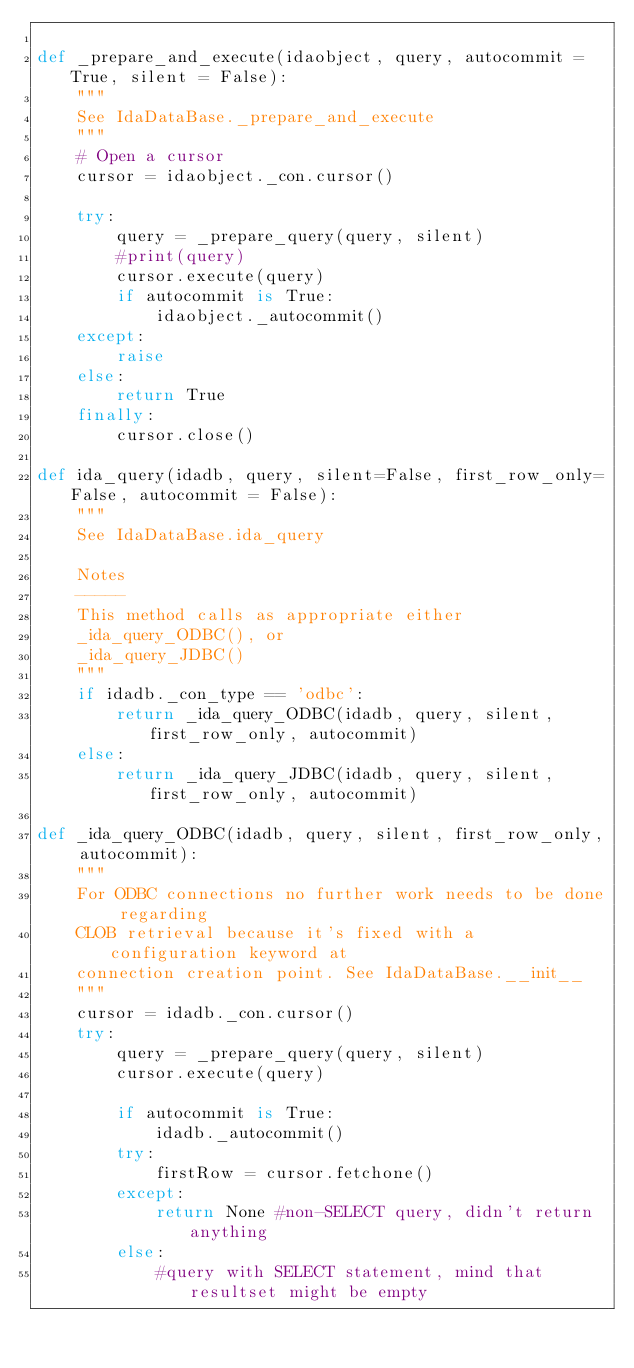Convert code to text. <code><loc_0><loc_0><loc_500><loc_500><_Python_>
def _prepare_and_execute(idaobject, query, autocommit = True, silent = False):
    """
    See IdaDataBase._prepare_and_execute
    """
    # Open a cursor
    cursor = idaobject._con.cursor()

    try:
        query = _prepare_query(query, silent)
        #print(query)
        cursor.execute(query)
        if autocommit is True:
            idaobject._autocommit()
    except:
        raise
    else:
        return True
    finally:
        cursor.close()

def ida_query(idadb, query, silent=False, first_row_only=False, autocommit = False):
    """
    See IdaDataBase.ida_query
    
    Notes
    -----
    This method calls as appropriate either 
    _ida_query_ODBC(), or 
    _ida_query_JDBC()
    """
    if idadb._con_type == 'odbc':
        return _ida_query_ODBC(idadb, query, silent, first_row_only, autocommit)
    else:
        return _ida_query_JDBC(idadb, query, silent, first_row_only, autocommit)

def _ida_query_ODBC(idadb, query, silent, first_row_only, autocommit):
    """
    For ODBC connections no further work needs to be done regarding
    CLOB retrieval because it's fixed with a configuration keyword at
    connection creation point. See IdaDataBase.__init__
    """
    cursor = idadb._con.cursor()
    try:
        query = _prepare_query(query, silent)
        cursor.execute(query)

        if autocommit is True:
            idadb._autocommit()            
        try:
            firstRow = cursor.fetchone()
        except:
            return None #non-SELECT query, didn't return anything
        else:
            #query with SELECT statement, mind that resultset might be empty</code> 